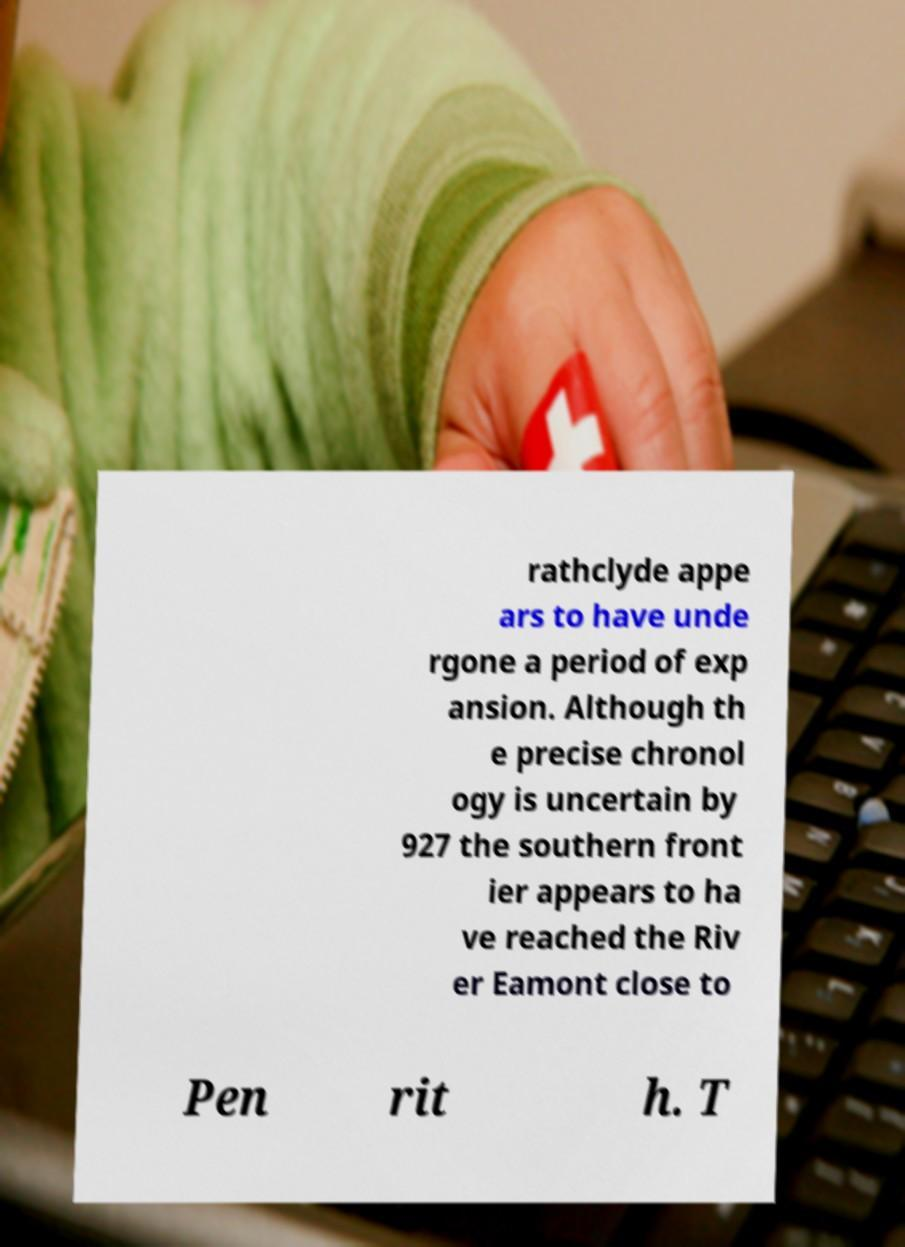For documentation purposes, I need the text within this image transcribed. Could you provide that? rathclyde appe ars to have unde rgone a period of exp ansion. Although th e precise chronol ogy is uncertain by 927 the southern front ier appears to ha ve reached the Riv er Eamont close to Pen rit h. T 